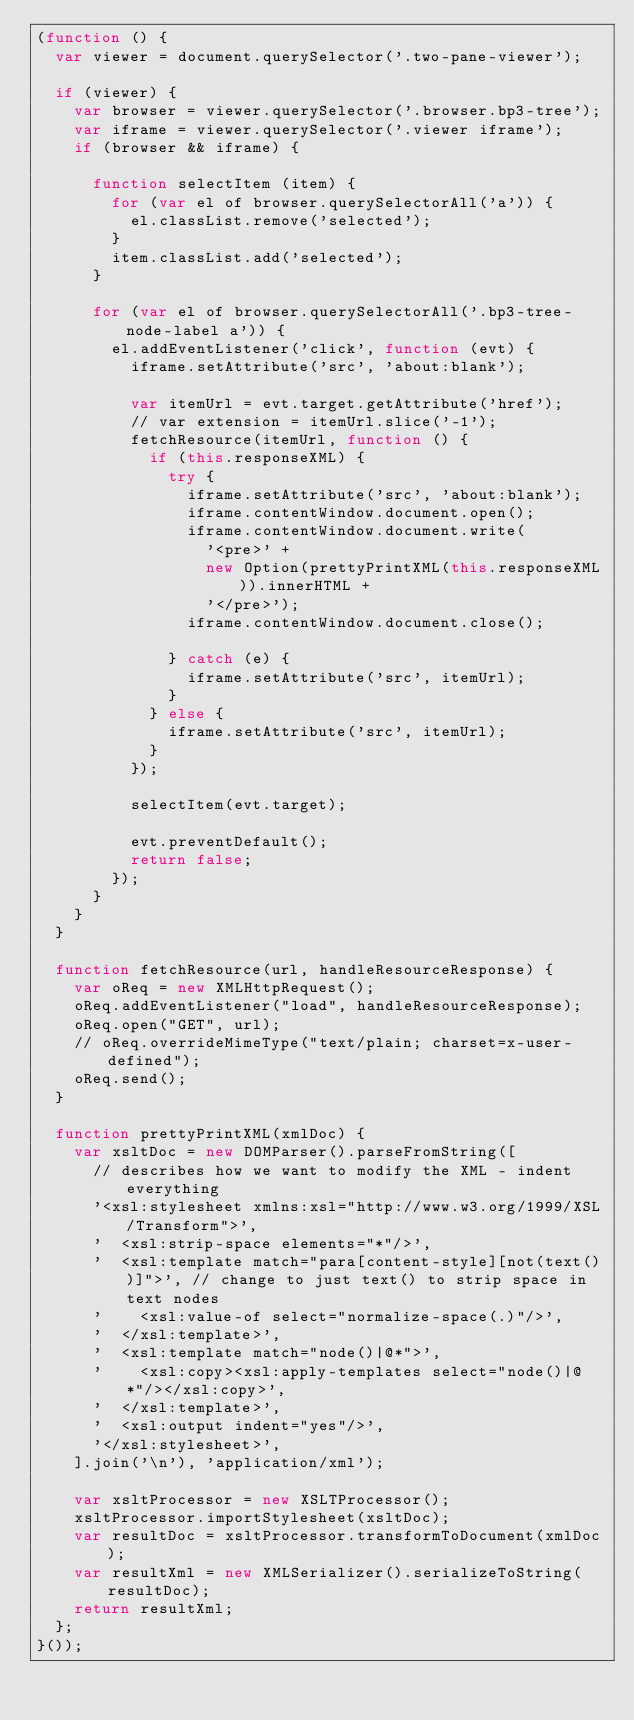<code> <loc_0><loc_0><loc_500><loc_500><_JavaScript_>(function () {
  var viewer = document.querySelector('.two-pane-viewer');

  if (viewer) {
    var browser = viewer.querySelector('.browser.bp3-tree');
    var iframe = viewer.querySelector('.viewer iframe');
    if (browser && iframe) {

      function selectItem (item) {
        for (var el of browser.querySelectorAll('a')) {
          el.classList.remove('selected');
        }
        item.classList.add('selected');
      }

      for (var el of browser.querySelectorAll('.bp3-tree-node-label a')) {
        el.addEventListener('click', function (evt) {
          iframe.setAttribute('src', 'about:blank');

          var itemUrl = evt.target.getAttribute('href');
          // var extension = itemUrl.slice('-1');
          fetchResource(itemUrl, function () {
            if (this.responseXML) {
              try {
                iframe.setAttribute('src', 'about:blank');
                iframe.contentWindow.document.open();
                iframe.contentWindow.document.write(
                  '<pre>' +
                  new Option(prettyPrintXML(this.responseXML)).innerHTML +
                  '</pre>');
                iframe.contentWindow.document.close();

              } catch (e) {
                iframe.setAttribute('src', itemUrl);
              }
            } else {
              iframe.setAttribute('src', itemUrl);
            }
          });

          selectItem(evt.target);

          evt.preventDefault();
          return false;
        });
      }
    }
  }

  function fetchResource(url, handleResourceResponse) {
    var oReq = new XMLHttpRequest();
    oReq.addEventListener("load", handleResourceResponse);
    oReq.open("GET", url);
    // oReq.overrideMimeType("text/plain; charset=x-user-defined");
    oReq.send();
  }

  function prettyPrintXML(xmlDoc) {
    var xsltDoc = new DOMParser().parseFromString([
      // describes how we want to modify the XML - indent everything
      '<xsl:stylesheet xmlns:xsl="http://www.w3.org/1999/XSL/Transform">',
      '  <xsl:strip-space elements="*"/>',
      '  <xsl:template match="para[content-style][not(text())]">', // change to just text() to strip space in text nodes
      '    <xsl:value-of select="normalize-space(.)"/>',
      '  </xsl:template>',
      '  <xsl:template match="node()|@*">',
      '    <xsl:copy><xsl:apply-templates select="node()|@*"/></xsl:copy>',
      '  </xsl:template>',
      '  <xsl:output indent="yes"/>',
      '</xsl:stylesheet>',
    ].join('\n'), 'application/xml');

    var xsltProcessor = new XSLTProcessor();    
    xsltProcessor.importStylesheet(xsltDoc);
    var resultDoc = xsltProcessor.transformToDocument(xmlDoc);
    var resultXml = new XMLSerializer().serializeToString(resultDoc);
    return resultXml;
  };
}());
</code> 